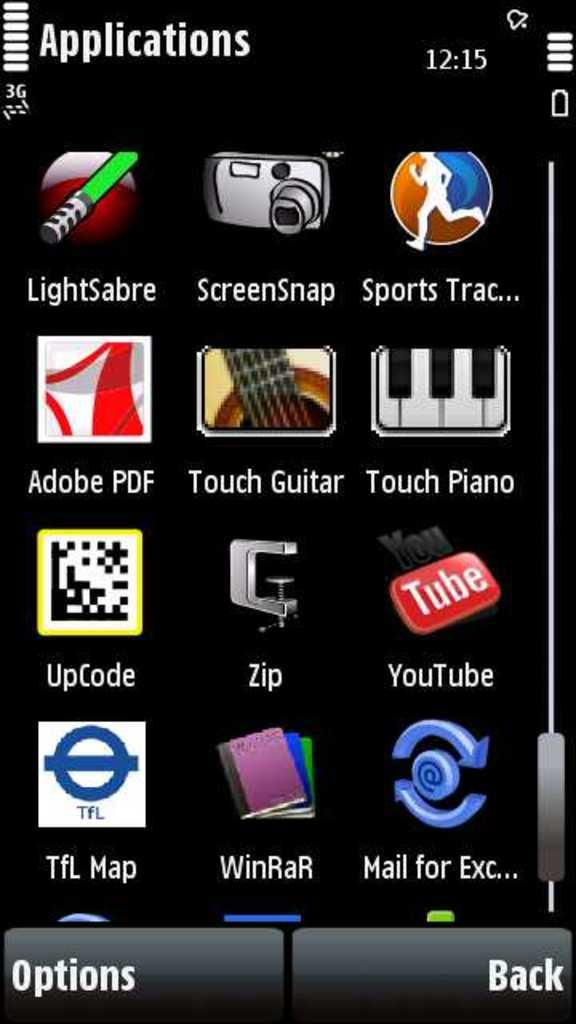<image>
Render a clear and concise summary of the photo. A screenshot of an app page is shown, the apps include YouTube, UpCode, Adobe PDF, and Touch Piano. 